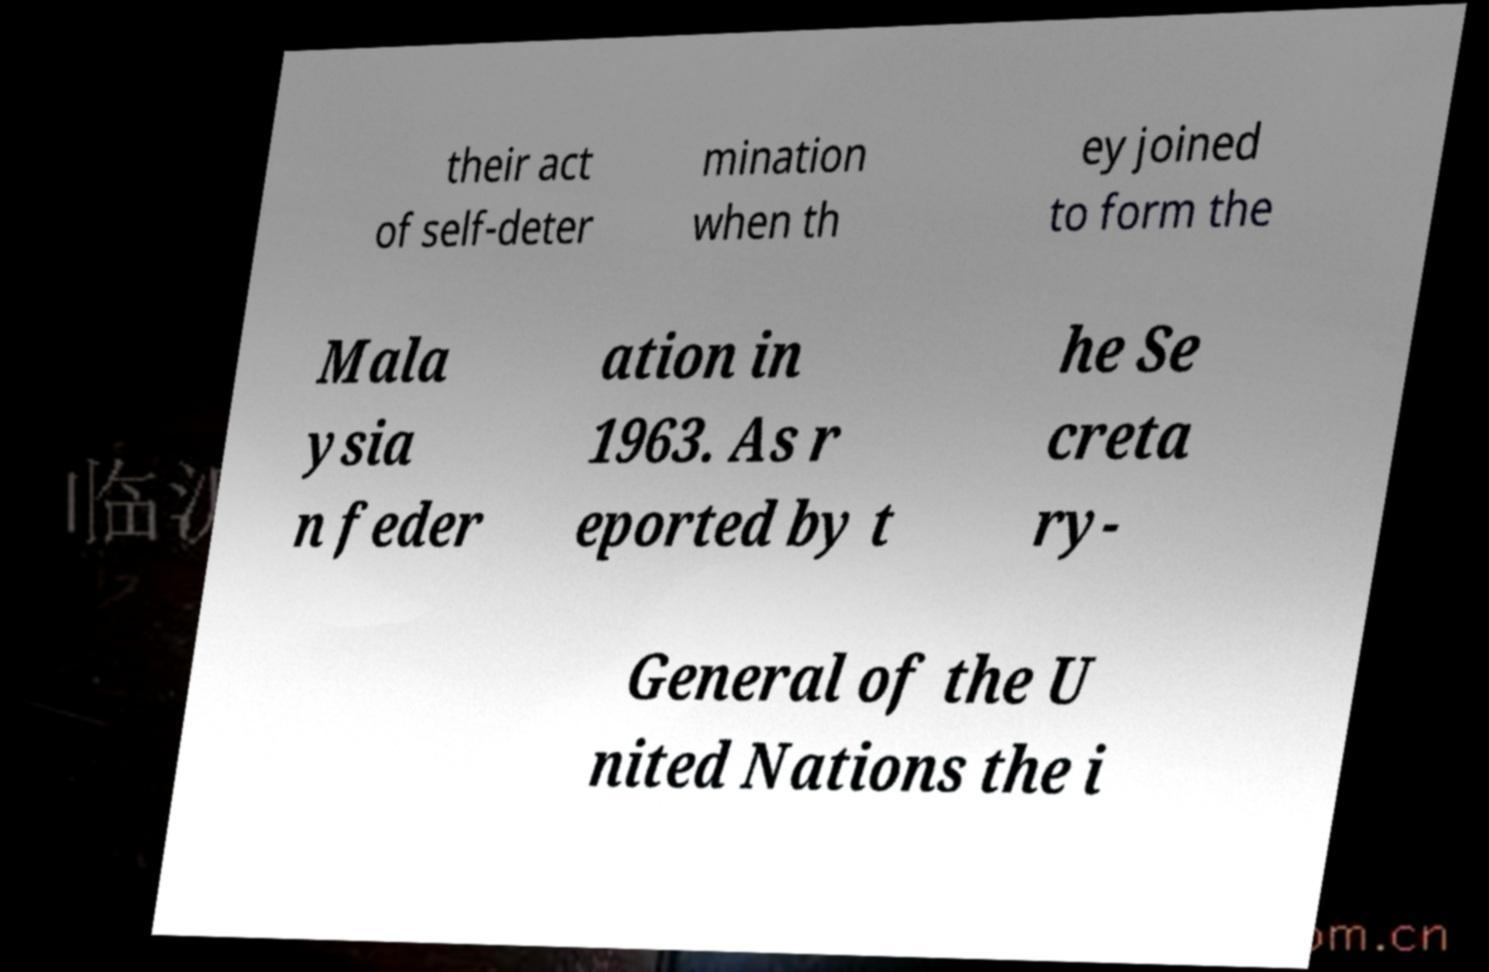I need the written content from this picture converted into text. Can you do that? their act of self-deter mination when th ey joined to form the Mala ysia n feder ation in 1963. As r eported by t he Se creta ry- General of the U nited Nations the i 